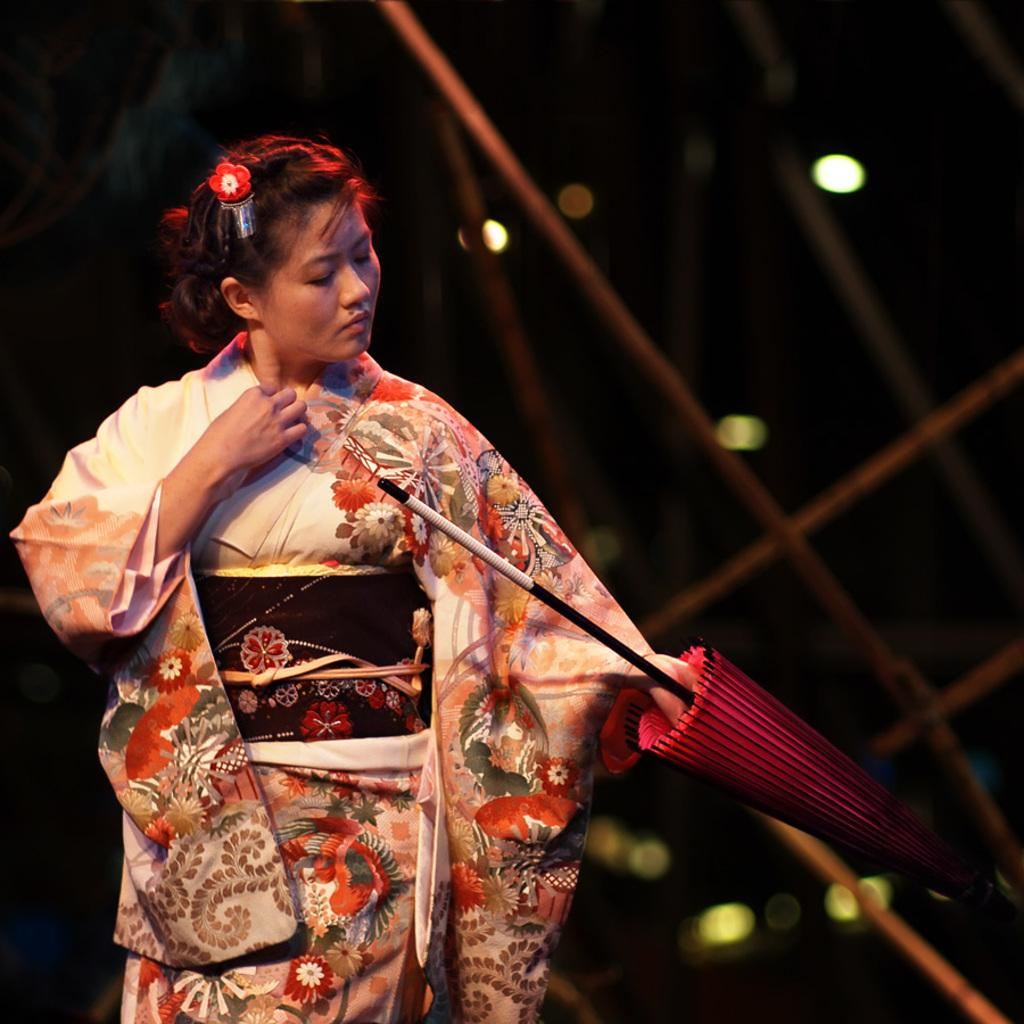Who is present in the image? There is a woman in the image. What is the woman holding in the image? The woman is holding an umbrella. What can be seen in the background of the image? There are lights, sticks, and trees in the background of the image. What type of error can be seen in the image? There is no error present in the image. What kind of locket is the woman wearing in the image? The woman is not wearing a locket in the image; she is holding an umbrella. 